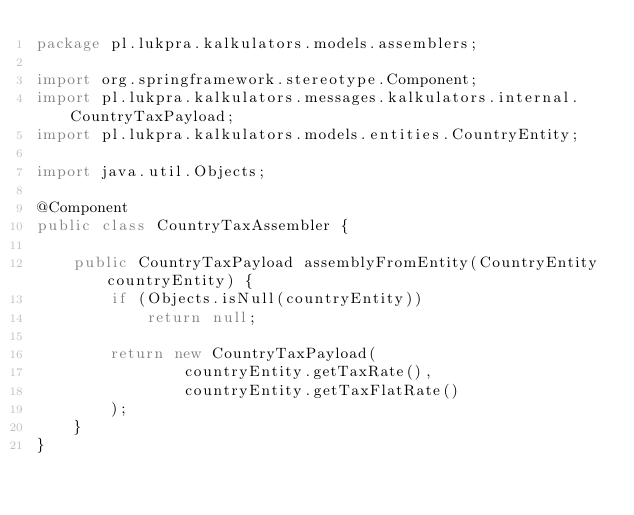Convert code to text. <code><loc_0><loc_0><loc_500><loc_500><_Java_>package pl.lukpra.kalkulators.models.assemblers;

import org.springframework.stereotype.Component;
import pl.lukpra.kalkulators.messages.kalkulators.internal.CountryTaxPayload;
import pl.lukpra.kalkulators.models.entities.CountryEntity;

import java.util.Objects;

@Component
public class CountryTaxAssembler {

    public CountryTaxPayload assemblyFromEntity(CountryEntity countryEntity) {
        if (Objects.isNull(countryEntity))
            return null;

        return new CountryTaxPayload(
                countryEntity.getTaxRate(),
                countryEntity.getTaxFlatRate()
        );
    }
}
</code> 